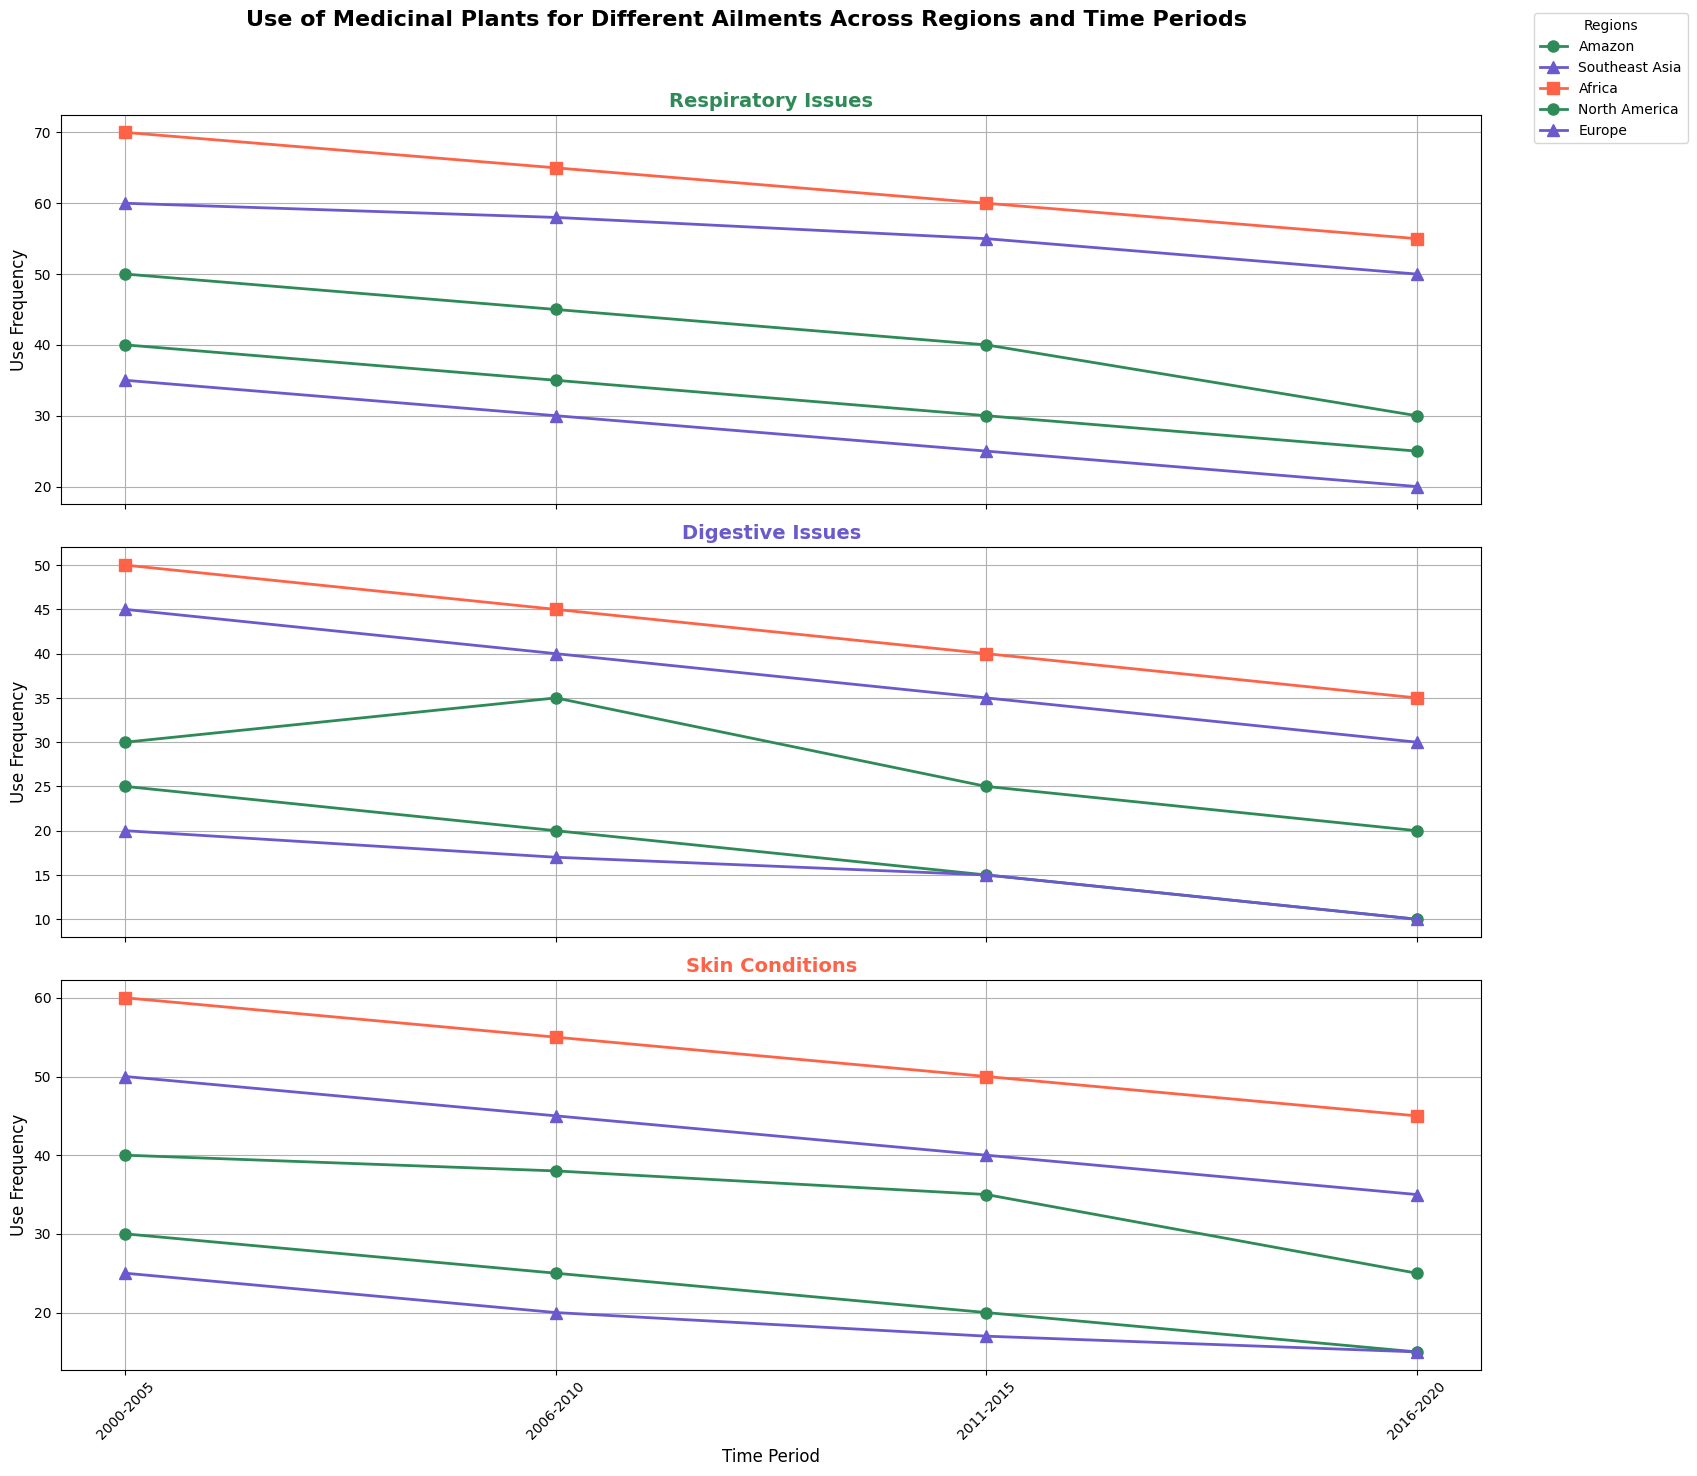Which region has the highest use frequency for respiratory issues in the 2000-2005 period? First, look at the data points for respiratory issues in the 2000-2005 period across all regions. Africa has a use frequency of 70, which is the highest compared to the other regions.
Answer: Africa How does the use frequency for digestive issues in the Amazon change from 2000-2020? Analyze the plot for digestive issues in the Amazon region across the given time periods. The values decrease from 30 (2000-2005) to 20 (2016-2020).
Answer: Decreases Which region experiences the most consistent decrease in use frequency for skin conditions from 2000 to 2020? Examine the plot for skin conditions across all regions, noting the trends. The Amazon shows a consistent decrease from 40 to 25.
Answer: Amazon Compare the use frequency for respiratory issues in Southeast Asia and North America during the 2016-2020 period. Look at the data points for the 2016-2020 time period. Southeast Asia has a use frequency of 50, and North America has a use frequency of 25.
Answer: Southeast Asia has higher use frequency Between 2000-2005 and 2016-2020, which region sees the largest drop in the use of medicinal plants for respiratory issues? Compare the 2000-2005 and 2016-2020 time periods for each region in the respiratory issues plot. The Amazon sees a drop from 50 to 30, which is a drop of 20.
Answer: Amazon 